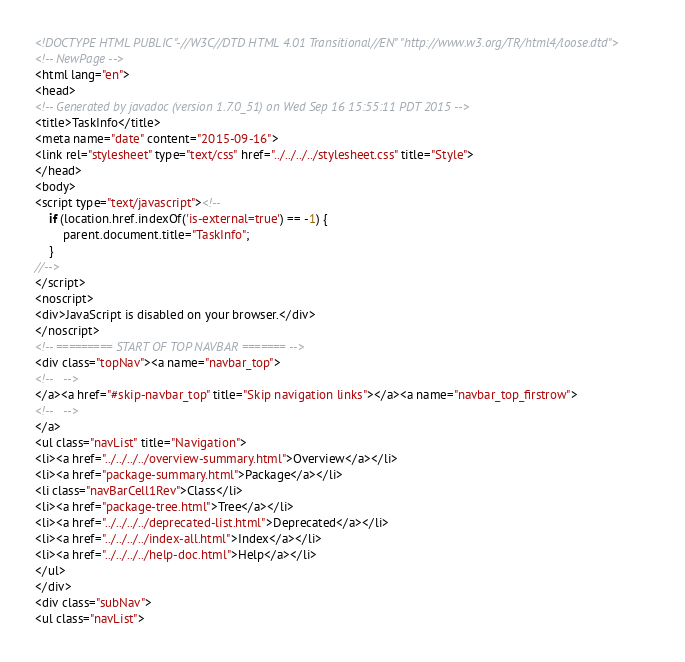<code> <loc_0><loc_0><loc_500><loc_500><_HTML_><!DOCTYPE HTML PUBLIC "-//W3C//DTD HTML 4.01 Transitional//EN" "http://www.w3.org/TR/html4/loose.dtd">
<!-- NewPage -->
<html lang="en">
<head>
<!-- Generated by javadoc (version 1.7.0_51) on Wed Sep 16 15:55:11 PDT 2015 -->
<title>TaskInfo</title>
<meta name="date" content="2015-09-16">
<link rel="stylesheet" type="text/css" href="../../../../stylesheet.css" title="Style">
</head>
<body>
<script type="text/javascript"><!--
    if (location.href.indexOf('is-external=true') == -1) {
        parent.document.title="TaskInfo";
    }
//-->
</script>
<noscript>
<div>JavaScript is disabled on your browser.</div>
</noscript>
<!-- ========= START OF TOP NAVBAR ======= -->
<div class="topNav"><a name="navbar_top">
<!--   -->
</a><a href="#skip-navbar_top" title="Skip navigation links"></a><a name="navbar_top_firstrow">
<!--   -->
</a>
<ul class="navList" title="Navigation">
<li><a href="../../../../overview-summary.html">Overview</a></li>
<li><a href="package-summary.html">Package</a></li>
<li class="navBarCell1Rev">Class</li>
<li><a href="package-tree.html">Tree</a></li>
<li><a href="../../../../deprecated-list.html">Deprecated</a></li>
<li><a href="../../../../index-all.html">Index</a></li>
<li><a href="../../../../help-doc.html">Help</a></li>
</ul>
</div>
<div class="subNav">
<ul class="navList"></code> 